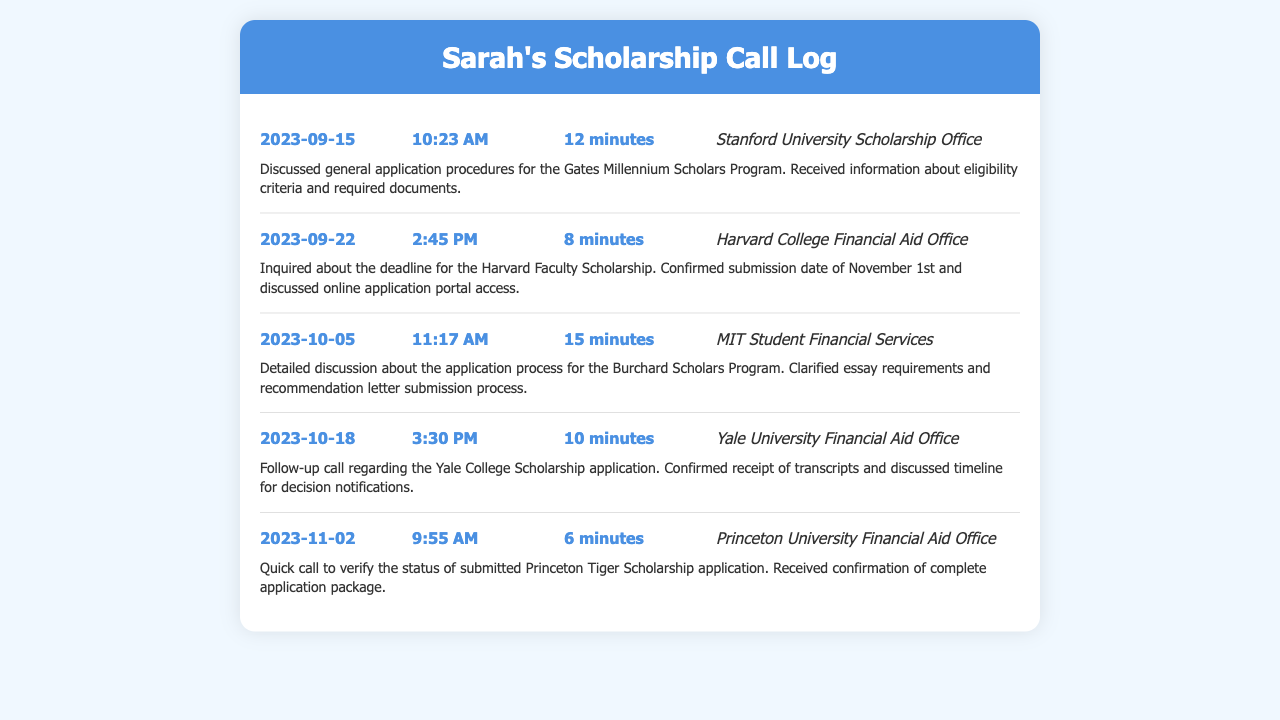what is the date of the first call? The first call was made on September 15, 2023.
Answer: September 15, 2023 who was the recipient of the call on October 5? The recipient of the call on October 5 was MIT Student Financial Services.
Answer: MIT Student Financial Services how long was the call with Harvard College Financial Aid Office? The call with Harvard College Financial Aid Office lasted 8 minutes.
Answer: 8 minutes what was discussed in the call on November 2? In the call on November 2, the status of the submitted Princeton Tiger Scholarship application was verified.
Answer: status of the submitted Princeton Tiger Scholarship application how many minutes was the longest call? The longest call lasted 15 minutes on October 5.
Answer: 15 minutes what is the application deadline for the Harvard Faculty Scholarship? The application deadline for the Harvard Faculty Scholarship is November 1st.
Answer: November 1st which call confirmed the receipt of transcripts? The call with Yale University Financial Aid Office confirmed the receipt of transcripts.
Answer: Yale University Financial Aid Office what information was clarified during the call about the Burchard Scholars Program? Essay requirements and recommendation letter submission process were clarified.
Answer: Essay requirements and recommendation letter submission process 